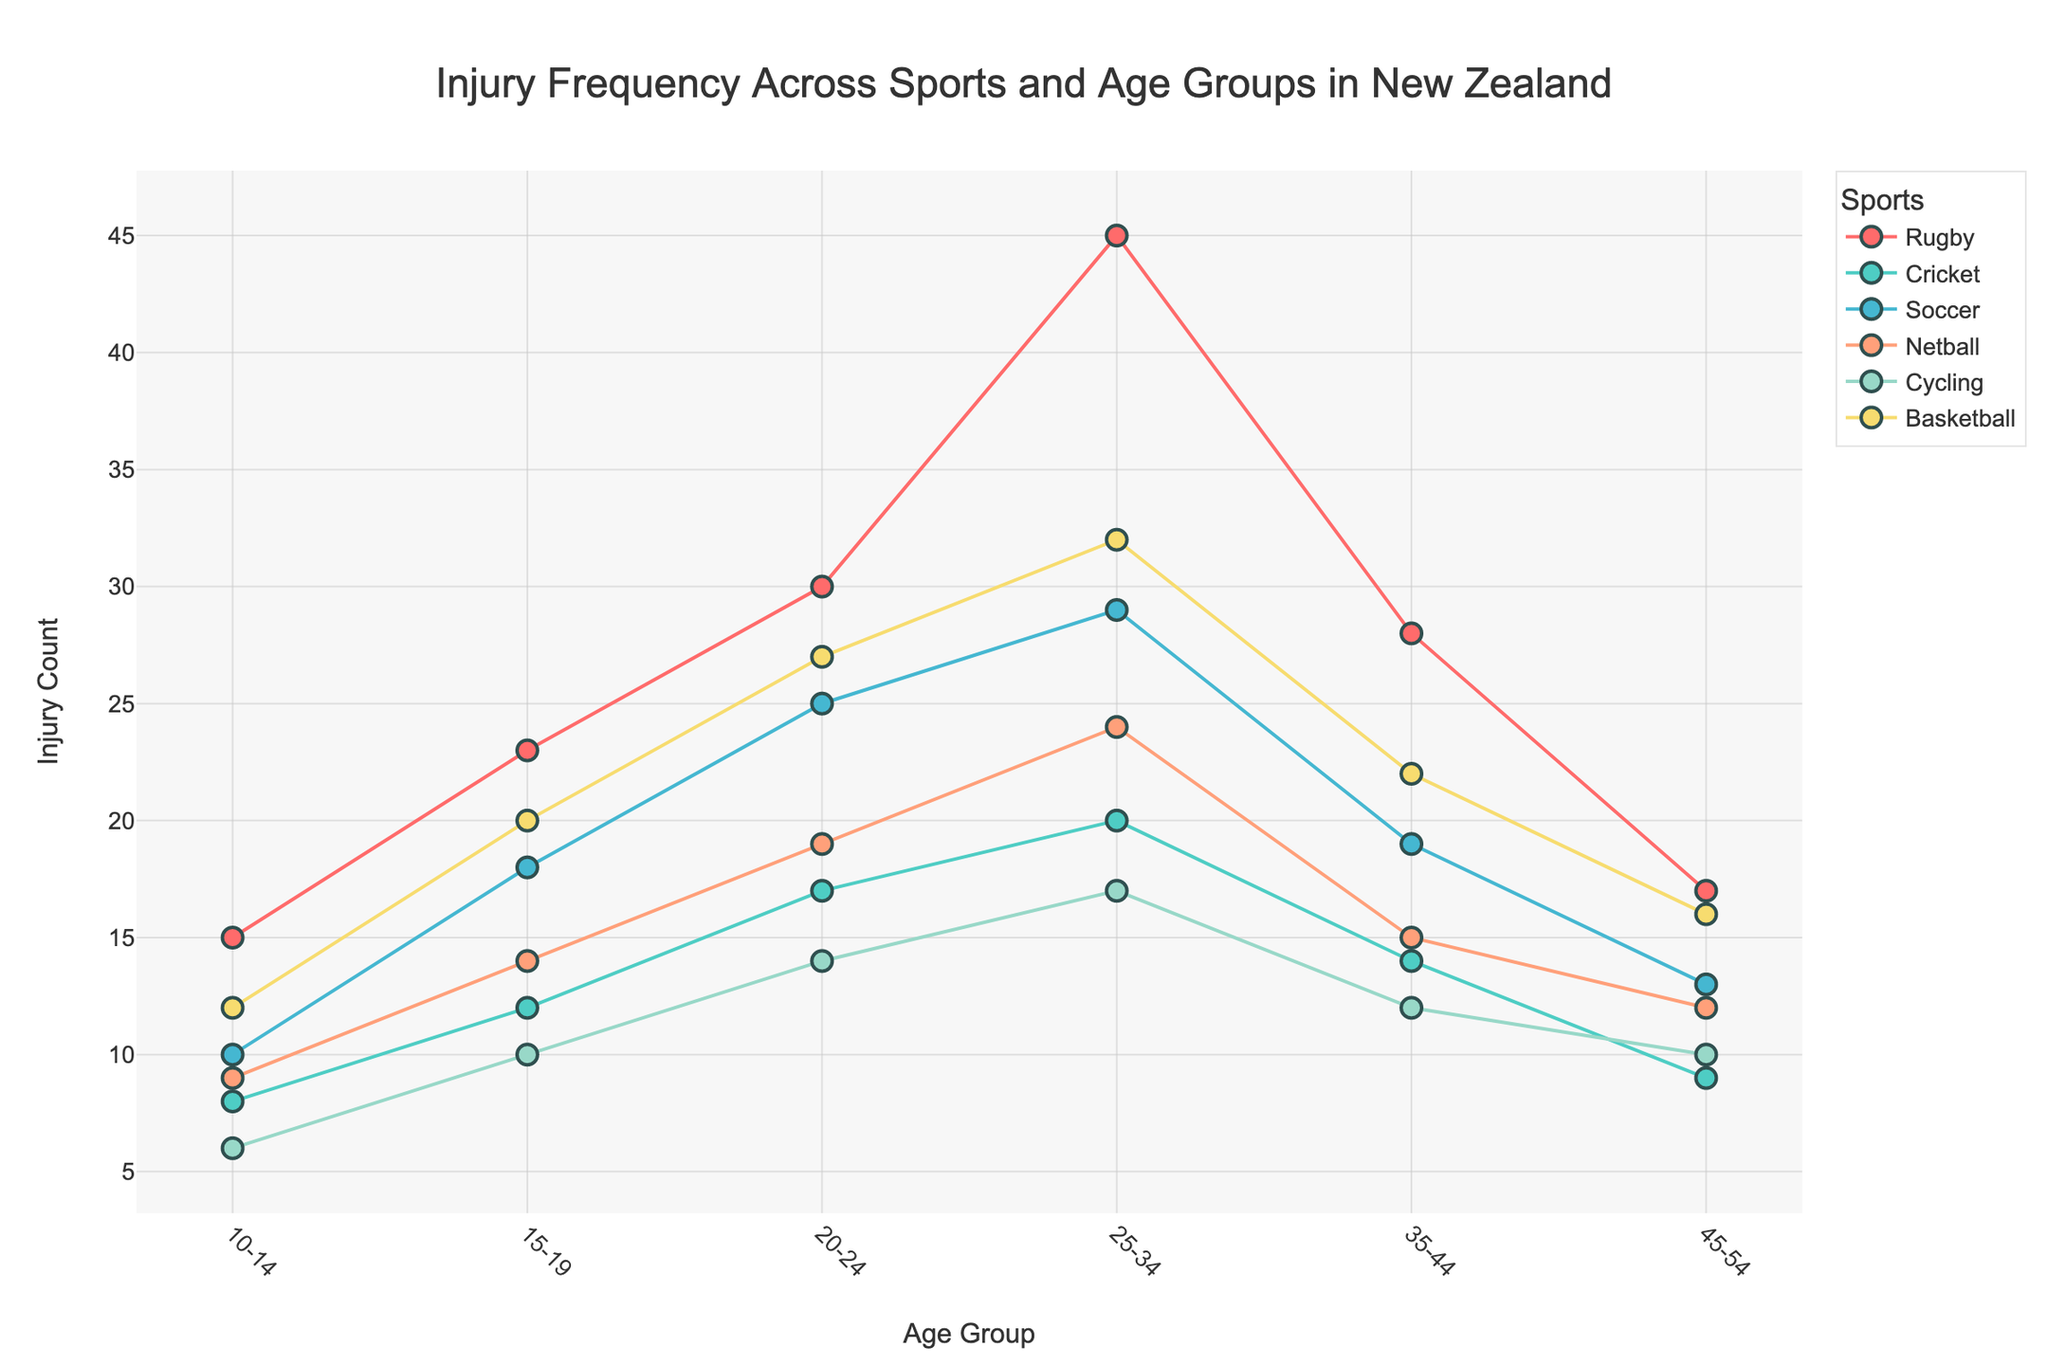What's the title of the plot? The title is located at the top of the plot and summarizes what the plot is about.
Answer: "Injury Frequency Across Sports and Age Groups in New Zealand" Which sport has the highest injury count in the 25-34 age group? Look at the 25-34 age group and compare the injury counts for each sport. Rugby has the highest count of 45.
Answer: Rugby How many points represent each sport in the plot? Each sport has a point for each age group. There are 6 age groups, so each sport should have 6 points.
Answer: 6 What is the injury count difference between Rugby and Cricket in the 20-24 age group? Subtract the injury count of Cricket from Rugby in the 20-24 age group. Rugby has 30 and Cricket has 17, so 30 - 17.
Answer: 13 Which age group has the lowest injury count for Netball? Look at the Netball points and identify the lowest value among the age groups. The age group with the lowest value (9) is 10-14.
Answer: 10-14 In which age group does Basketball peak in injury count? Identify the highest injury count for Basketball and see which age group it corresponds to. The peak injury count (32) is in the 25-34 age group.
Answer: 25-34 What's the sum of the injury counts for Soccer across all age groups? Add up the injury counts of Soccer across all age groups: 10 + 18 + 25 + 29 + 19 + 13 = 114.
Answer: 114 Compare the injury trends of Rugby and Soccer. Which sport sees a higher increase in injury count from the 10-14 age group to the 25-34 age group? Rugby increases from 15 to 45, which is an increase of 30. Soccer increases from 10 to 29, which is an increase of 19.
Answer: Rugby Which age group has the most balanced distribution of injury counts across different sports? Compare the injury counts in each age group and find the one where the values are closest to each other. The 35-44 age group has relatively balanced counts (Rugby: 28, Cricket: 14, Soccer: 19, Netball: 15, Cycling: 12, Basketball: 22).
Answer: 35-44 How does the injury frequency for Cycling change with age? Look at the injury counts for Cycling across age groups: 6 (10-14), 10 (15-19), 14 (20-24), 17 (25-34), 12 (35-44), 10 (45-54). The count generally increases up to 25-34 and then decreases.
Answer: Increases up to 25-34 then decreases 